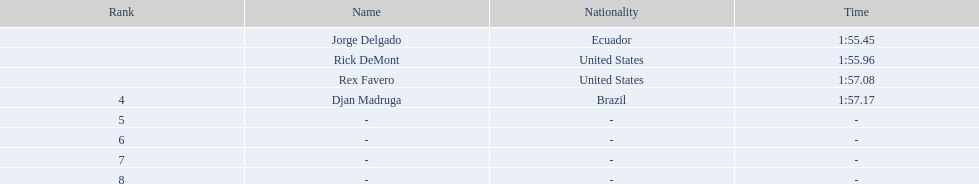0 1:57.17. Parse the full table. {'header': ['Rank', 'Name', 'Nationality', 'Time'], 'rows': [['', 'Jorge Delgado', 'Ecuador', '1:55.45'], ['', 'Rick DeMont', 'United States', '1:55.96'], ['', 'Rex Favero', 'United States', '1:57.08'], ['4', 'Djan Madruga', 'Brazil', '1:57.17'], ['5', '-', '-', '-'], ['6', '-', '-', '-'], ['7', '-', '-', '-'], ['8', '-', '-', '-']]} 